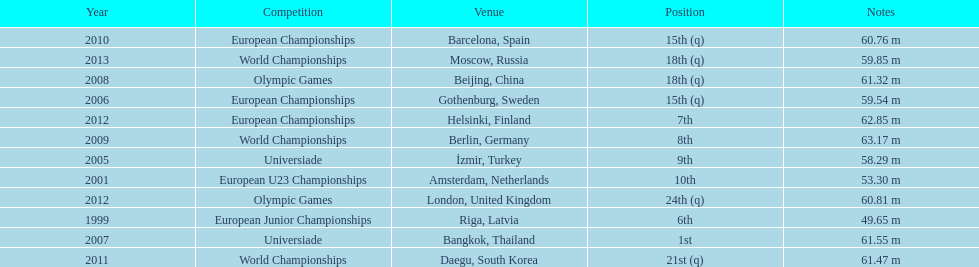What was the last competition he was in before the 2012 olympics? European Championships. Could you parse the entire table as a dict? {'header': ['Year', 'Competition', 'Venue', 'Position', 'Notes'], 'rows': [['2010', 'European Championships', 'Barcelona, Spain', '15th (q)', '60.76 m'], ['2013', 'World Championships', 'Moscow, Russia', '18th (q)', '59.85 m'], ['2008', 'Olympic Games', 'Beijing, China', '18th (q)', '61.32 m'], ['2006', 'European Championships', 'Gothenburg, Sweden', '15th (q)', '59.54 m'], ['2012', 'European Championships', 'Helsinki, Finland', '7th', '62.85 m'], ['2009', 'World Championships', 'Berlin, Germany', '8th', '63.17 m'], ['2005', 'Universiade', 'İzmir, Turkey', '9th', '58.29 m'], ['2001', 'European U23 Championships', 'Amsterdam, Netherlands', '10th', '53.30 m'], ['2012', 'Olympic Games', 'London, United Kingdom', '24th (q)', '60.81 m'], ['1999', 'European Junior Championships', 'Riga, Latvia', '6th', '49.65 m'], ['2007', 'Universiade', 'Bangkok, Thailand', '1st', '61.55 m'], ['2011', 'World Championships', 'Daegu, South Korea', '21st (q)', '61.47 m']]} 